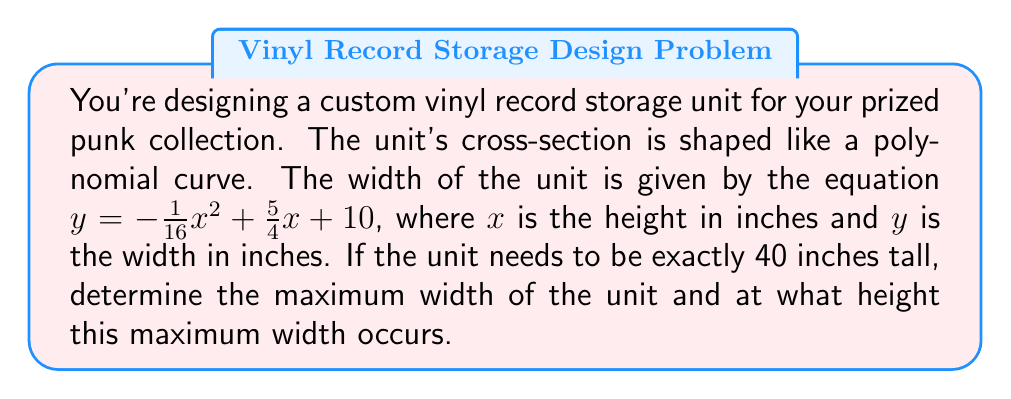Provide a solution to this math problem. Let's approach this step-by-step:

1) We're given the polynomial equation: $y = -\frac{1}{16}x^2 + \frac{5}{4}x + 10$

2) To find the maximum width, we need to find the vertex of this parabola. Since the coefficient of $x^2$ is negative, this parabola opens downward and the vertex will represent the maximum point.

3) For a quadratic equation in the form $ax^2 + bx + c$, the x-coordinate of the vertex is given by $x = -\frac{b}{2a}$

4) In our equation, $a = -\frac{1}{16}$, $b = \frac{5}{4}$

5) Plugging these values:

   $x = -\frac{\frac{5}{4}}{2(-\frac{1}{16})} = -\frac{5}{4} \cdot -\frac{16}{2} = 10$

6) So the maximum width occurs at a height of 10 inches.

7) To find the maximum width, we plug x = 10 into our original equation:

   $y = -\frac{1}{16}(10)^2 + \frac{5}{4}(10) + 10$
   $= -\frac{100}{16} + \frac{50}{4} + 10$
   $= -6.25 + 12.5 + 10$
   $= 16.25$

8) Therefore, the maximum width is 16.25 inches.

9) Note that the unit is 40 inches tall, which is within the domain of our function (the parabola extends beyond the maximum point).
Answer: Maximum width: 16.25 inches; occurs at height: 10 inches 